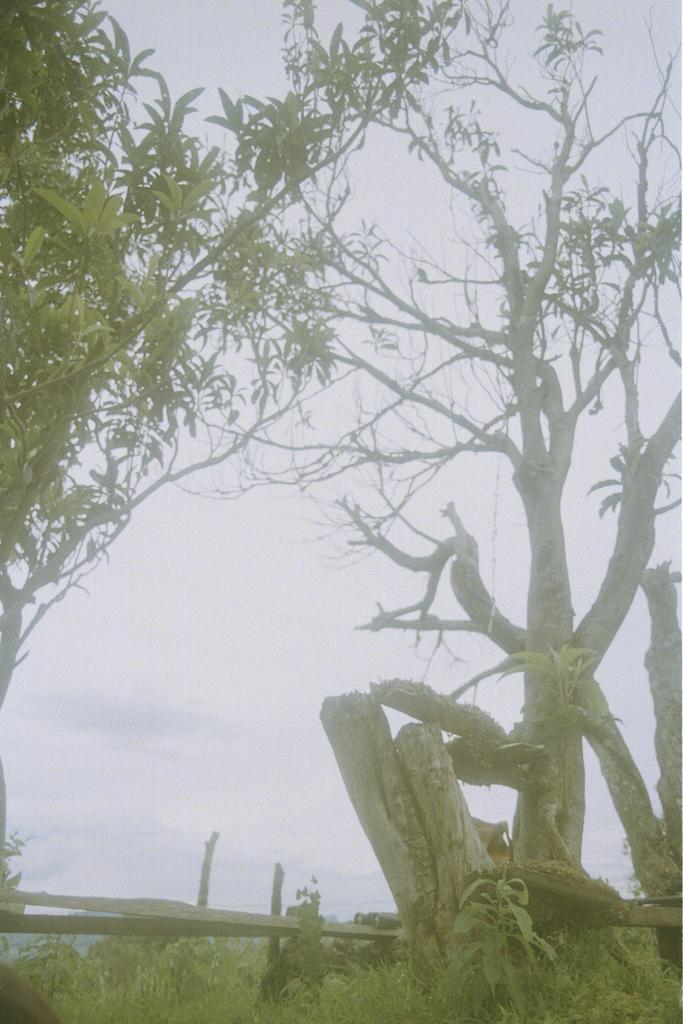What type of vegetation can be seen in the image? There are trees in the image. What structure is present in the image? There is a fence in the image. What is visible at the bottom of the image? Grass is visible at the bottom of the image. What is visible at the top of the image? The sky is visible at the top of the image. How many masks can be seen hanging on the fence in the image? There are no masks present in the image; it only features trees, a fence, grass, and the sky. What process is being carried out by the trees in the image? Trees do not perform processes like humans; they are stationary plants in the image. 